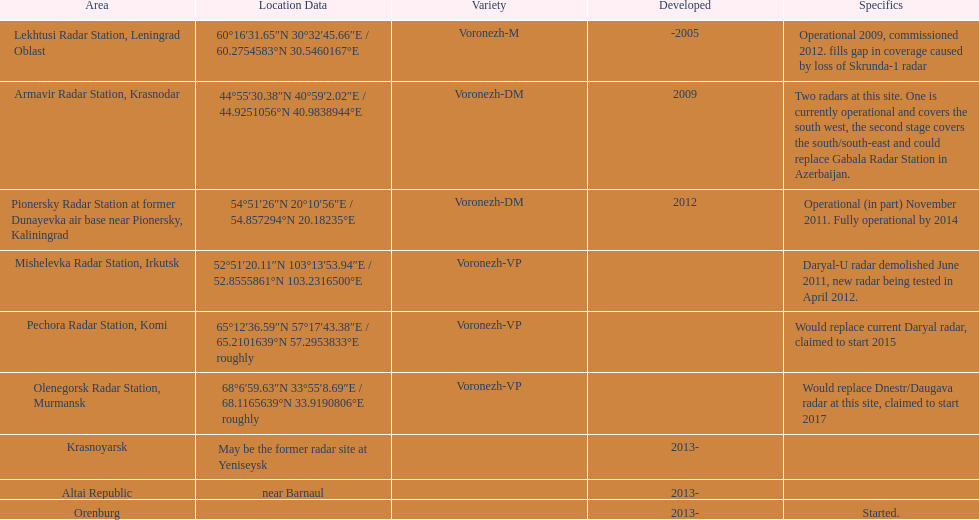What is the total number of locations? 9. 